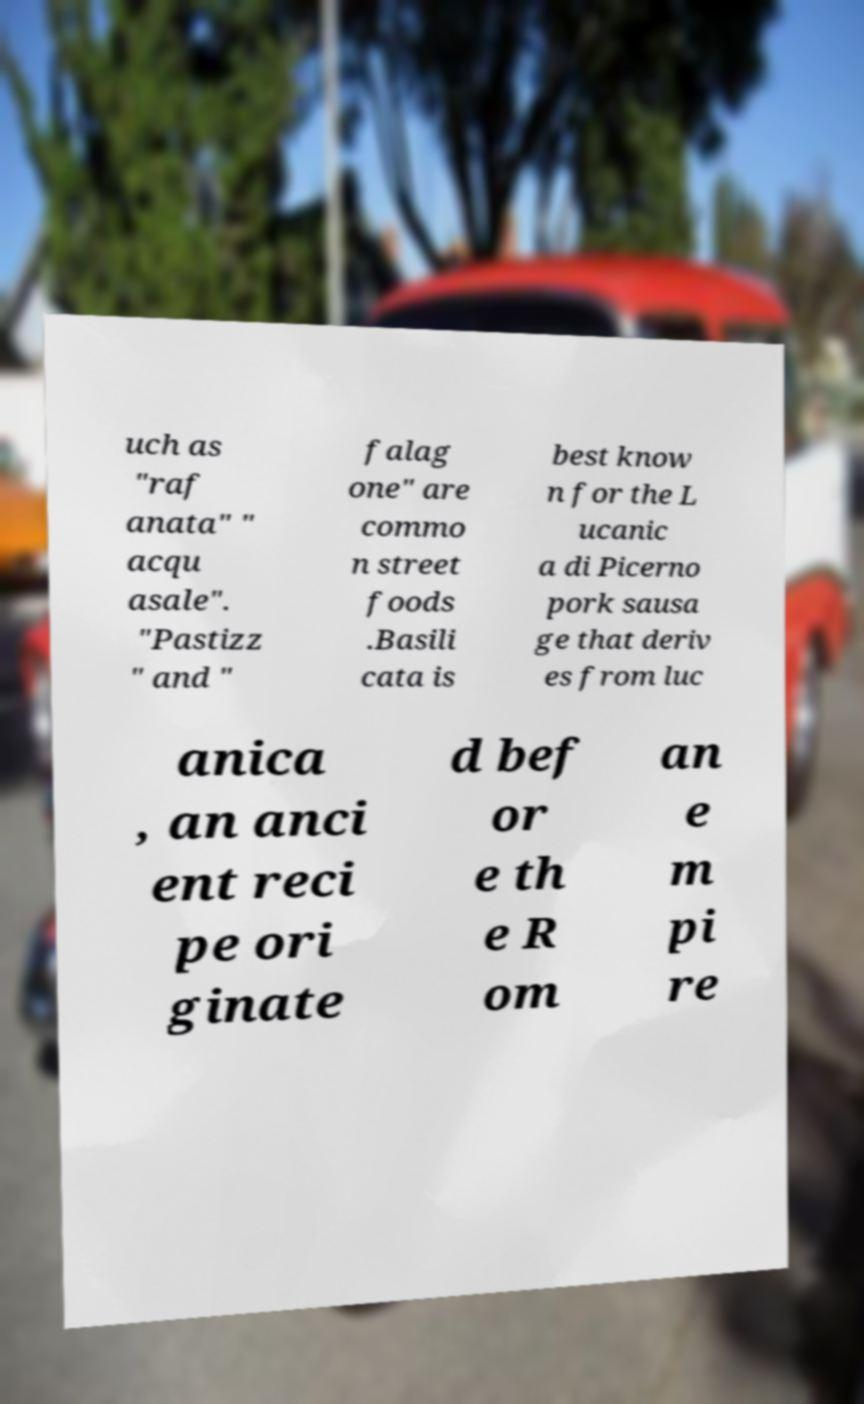Can you accurately transcribe the text from the provided image for me? uch as "raf anata" " acqu asale". "Pastizz " and " falag one" are commo n street foods .Basili cata is best know n for the L ucanic a di Picerno pork sausa ge that deriv es from luc anica , an anci ent reci pe ori ginate d bef or e th e R om an e m pi re 